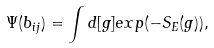<formula> <loc_0><loc_0><loc_500><loc_500>\Psi ( b _ { i j } ) = \int d [ g ] e x p ( - S _ { E } ( g ) ) ,</formula> 